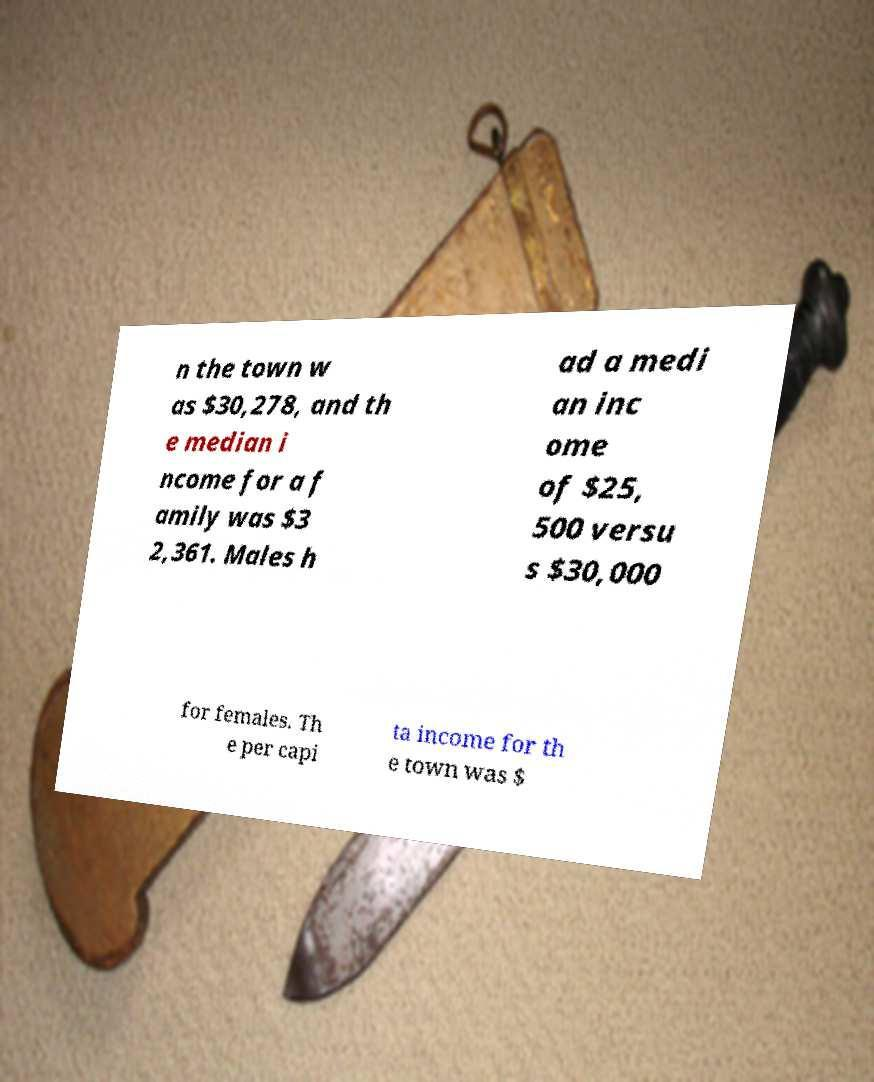I need the written content from this picture converted into text. Can you do that? n the town w as $30,278, and th e median i ncome for a f amily was $3 2,361. Males h ad a medi an inc ome of $25, 500 versu s $30,000 for females. Th e per capi ta income for th e town was $ 